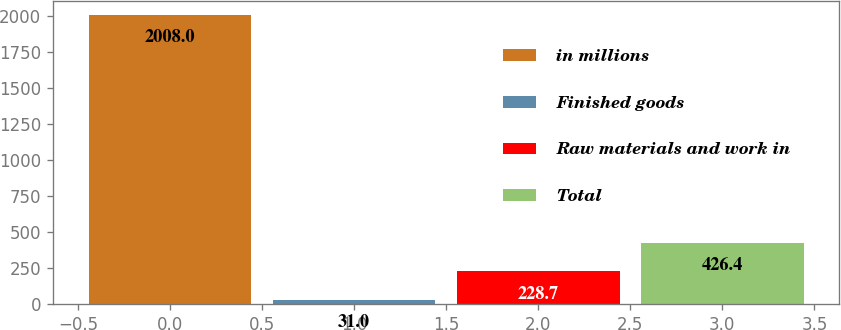<chart> <loc_0><loc_0><loc_500><loc_500><bar_chart><fcel>in millions<fcel>Finished goods<fcel>Raw materials and work in<fcel>Total<nl><fcel>2008<fcel>31<fcel>228.7<fcel>426.4<nl></chart> 